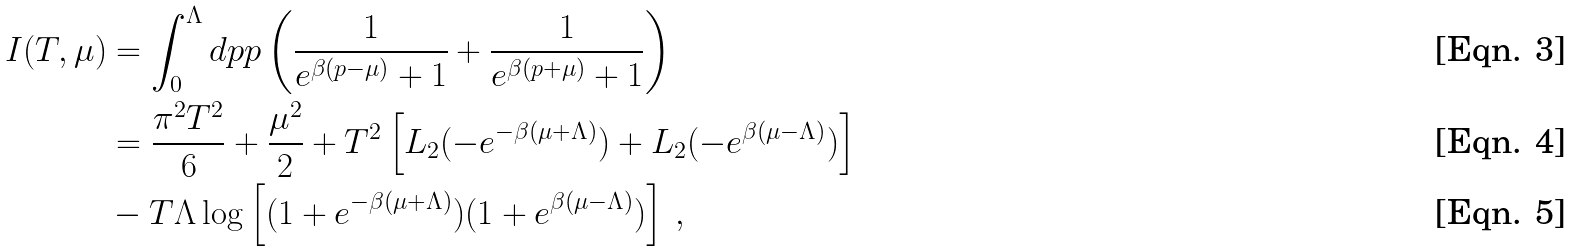Convert formula to latex. <formula><loc_0><loc_0><loc_500><loc_500>I ( T , \mu ) & = \int _ { 0 } ^ { \Lambda } d p p \left ( \frac { 1 } { e ^ { \beta ( p - \mu ) } + 1 } + \frac { 1 } { e ^ { \beta ( p + \mu ) } + 1 } \right ) \\ & = \frac { \pi ^ { 2 } T ^ { 2 } } { 6 } + \frac { \mu ^ { 2 } } { 2 } + T ^ { 2 } \left [ L _ { 2 } ( - e ^ { - \beta ( \mu + \Lambda ) } ) + L _ { 2 } ( - e ^ { \beta ( \mu - \Lambda ) } ) \right ] \\ & - T \Lambda \log \left [ ( 1 + e ^ { - \beta ( \mu + \Lambda ) } ) ( 1 + e ^ { \beta ( \mu - \Lambda ) } ) \right ] \, ,</formula> 